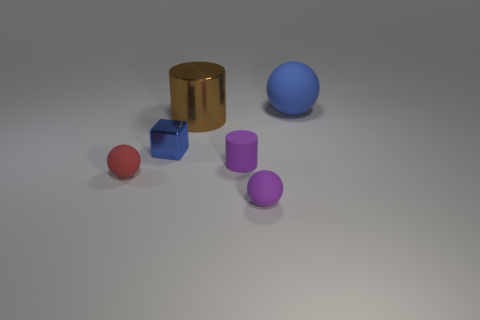Add 1 small purple matte cylinders. How many objects exist? 7 Subtract all cylinders. How many objects are left? 4 Subtract all small yellow shiny objects. Subtract all big shiny objects. How many objects are left? 5 Add 4 rubber spheres. How many rubber spheres are left? 7 Add 2 brown cylinders. How many brown cylinders exist? 3 Subtract 0 cyan blocks. How many objects are left? 6 